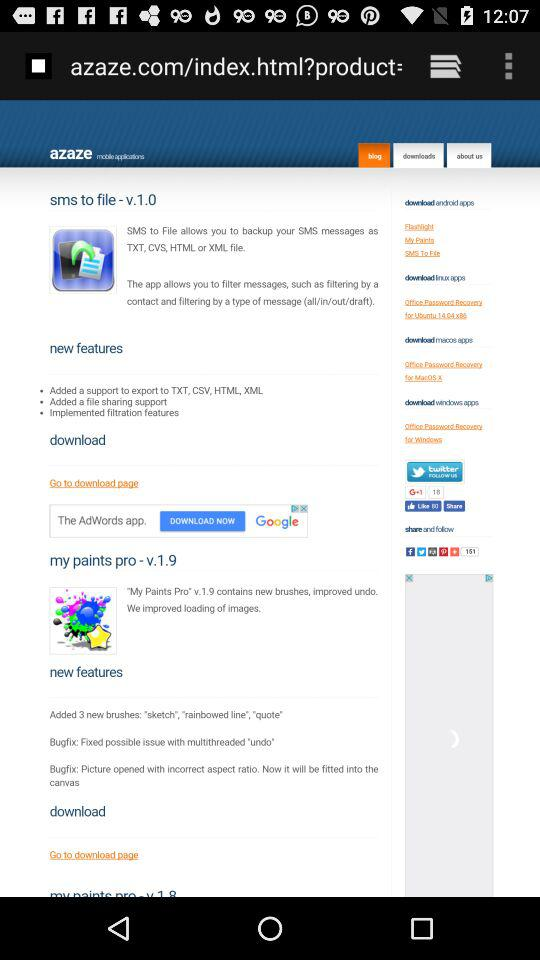What are the new features of "my paints pro - v.1.9"? The new features are "Added 3 new brushes: "sketch", "rainbowed line", "quote"", "Bugfix: Fixed possible issue with multithreaded "undo"" and "Bugfix: Picture opened with incorrect aspect ratio. Now it will be fitted into the canvas". 